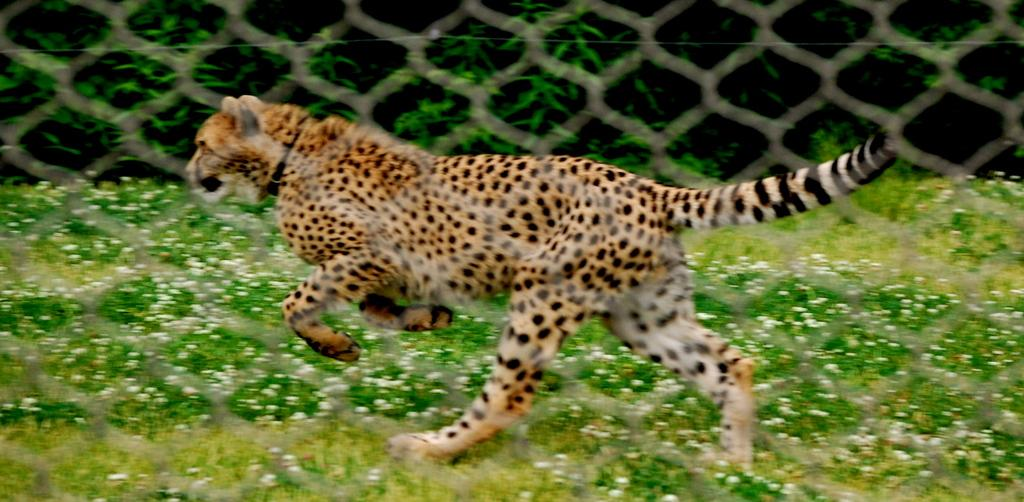What animal is the main subject of the image? There is a cheetah in the image. What is the cheetah's environment in the image? The cheetah is inside a mesh fence. What type of surface is the cheetah running on? The cheetah is running on a grass surface. What can be seen in the background of the image? There are trees on the other side of the cheetah. What type of suit is the cheetah wearing in the image? The cheetah is not wearing a suit in the image; it is a wild animal in its natural environment. 